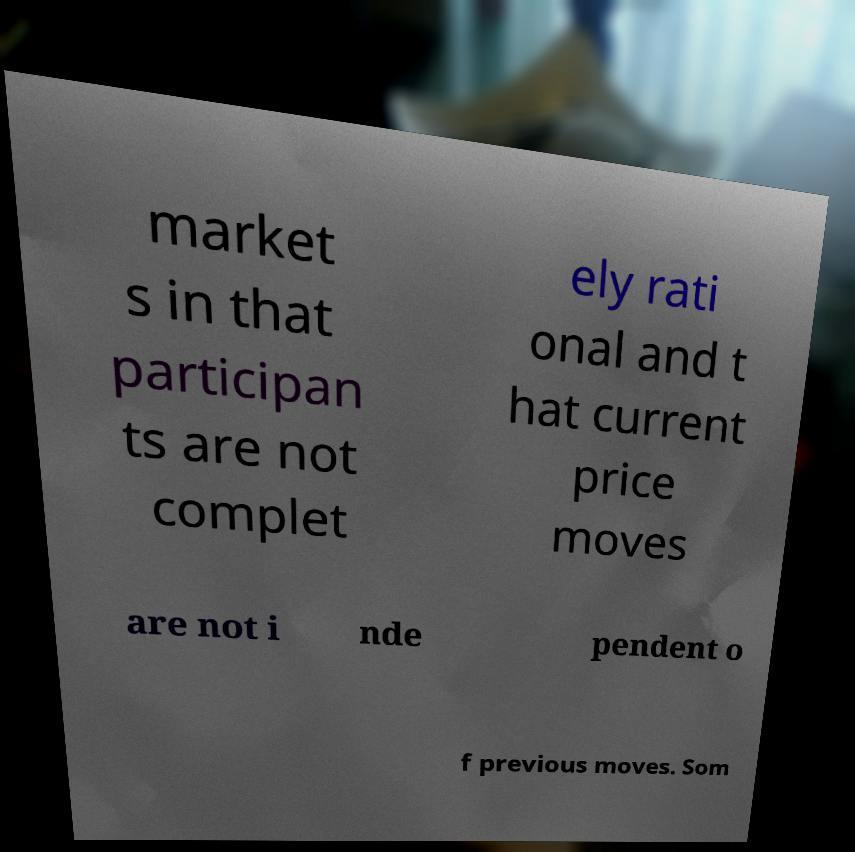Please identify and transcribe the text found in this image. market s in that participan ts are not complet ely rati onal and t hat current price moves are not i nde pendent o f previous moves. Som 